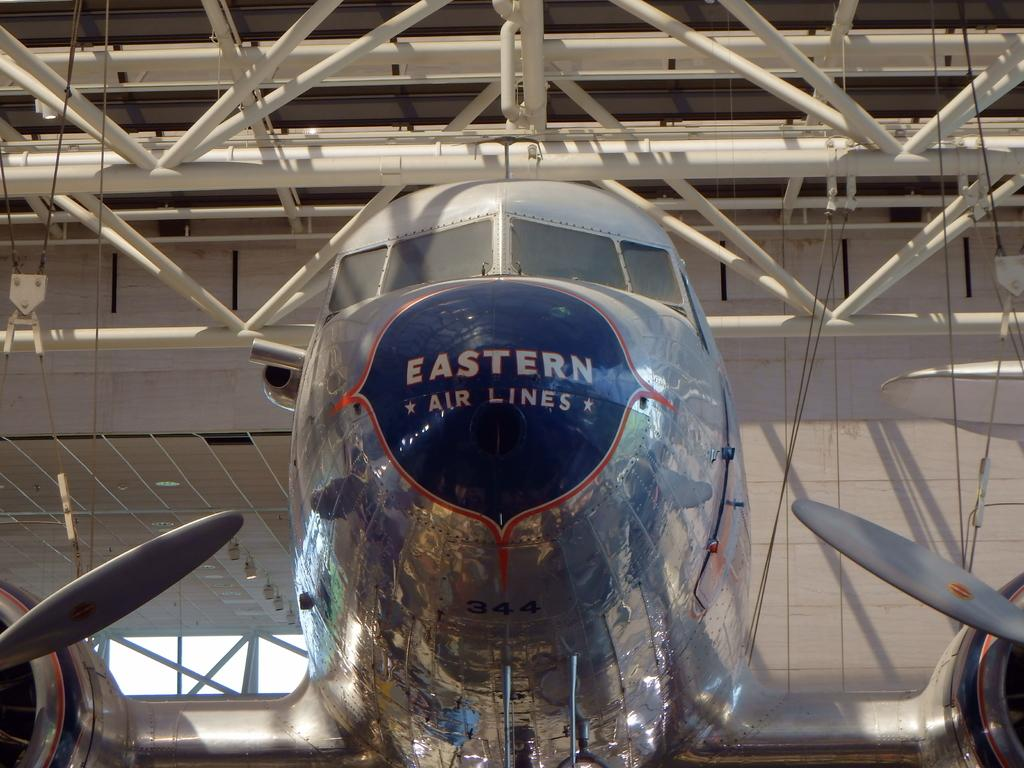<image>
Provide a brief description of the given image. The nose of an Easter Air Lines airplane shown in a hanger. 